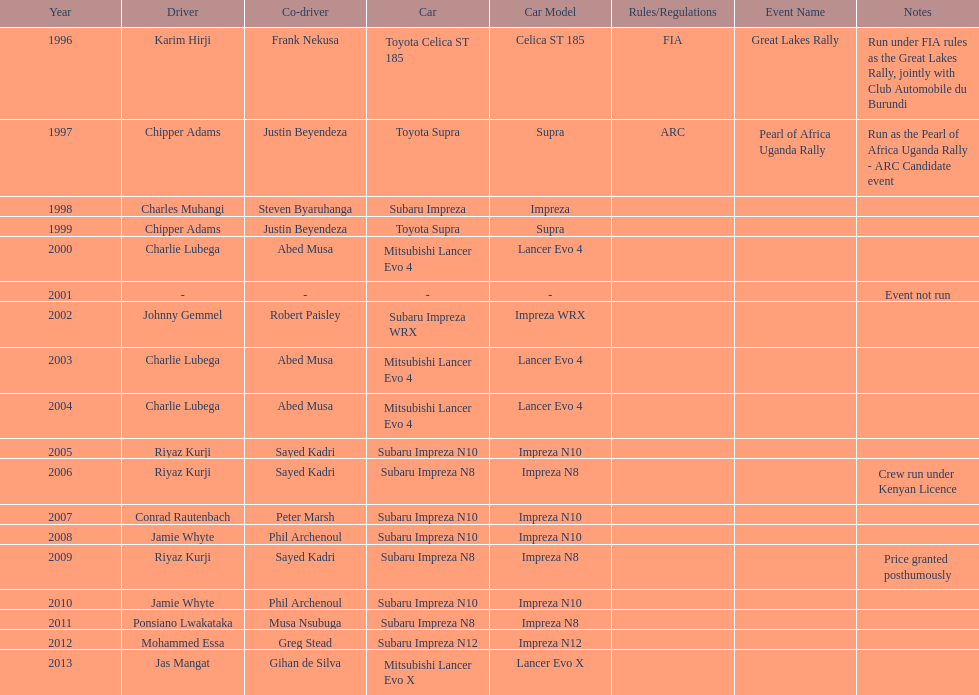Chipper adams and justin beyendeza have how mnay wins? 2. 